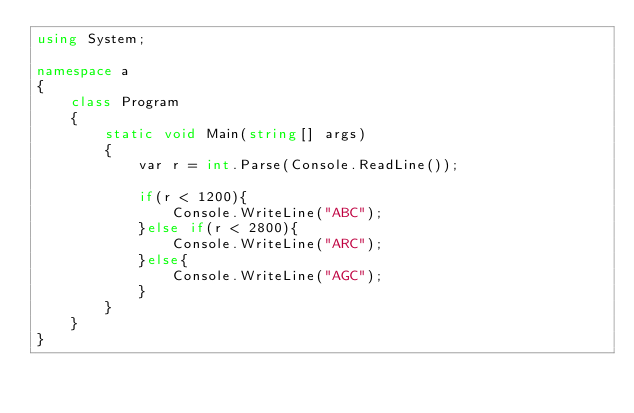<code> <loc_0><loc_0><loc_500><loc_500><_C#_>using System;

namespace a
{
    class Program
    {
        static void Main(string[] args)
        {
            var r = int.Parse(Console.ReadLine());

            if(r < 1200){
                Console.WriteLine("ABC");
            }else if(r < 2800){
                Console.WriteLine("ARC");
            }else{
                Console.WriteLine("AGC");
            }
        }
    }
}
</code> 